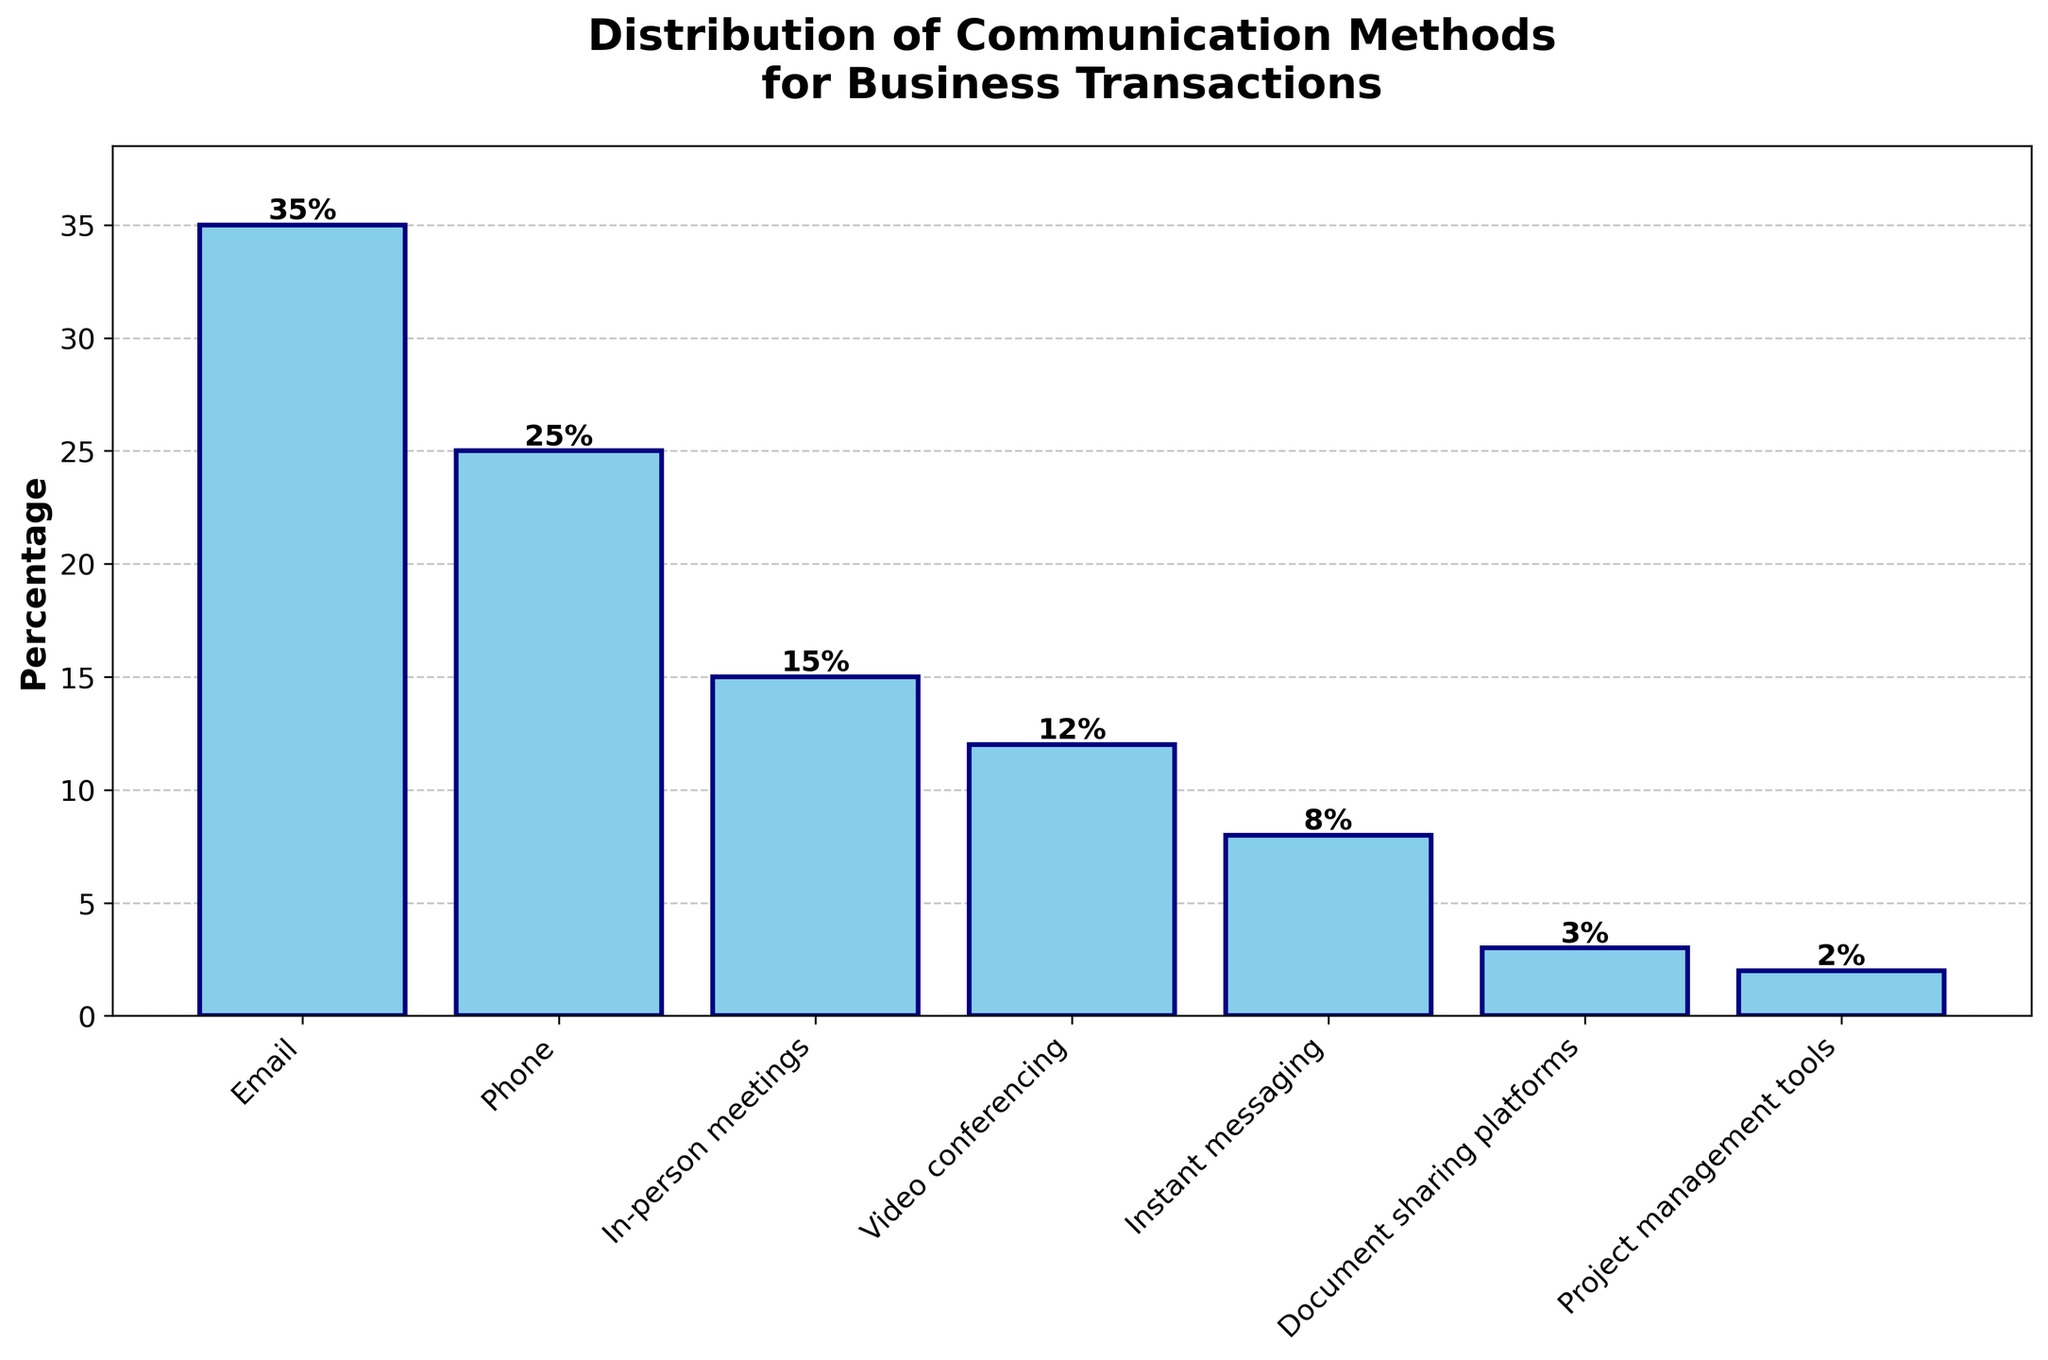What's the total percentage of methods that use digital communication (Email, Phone, Video conferencing, Instant messaging, Document sharing platforms)? Sum the percentages of Email (35), Phone (25), Video conferencing (12), Instant messaging (8), and Document sharing platforms (3). 35 + 25 + 12 + 8 + 3 = 83
Answer: 83 Which communication method has the highest percentage? Identify the tallest bar in the bar chart, which represents Email at 35%.
Answer: Email What is the percentage difference between Email and Phone? Subtract the percentage of Phone (25) from Email (35). 35 - 25 = 10
Answer: 10 What is the combined percentage of In-person meetings and Video conferencing? Add the percentages of In-person meetings (15) and Video conferencing (12). 15 + 12 = 27
Answer: 27 Are there more methods that have percentages above 10% or below 10%? Count the methods above 10% (Email, Phone, In-person meetings, Video conferencing) and below 10% (Instant messaging, Document sharing platforms, Project management tools). 4 methods above 10%, 3 methods below 10%.
Answer: Above 10% What percentage of methods use primarily face-to-face communication (In-person meetings and Video conferencing)? Sum the percentages of In-person meetings (15) and Video conferencing (12). 15 + 12 = 27
Answer: 27 How does the percentage of Instant messaging compare to that of Document sharing platforms and Project management tools combined? Compare the percentage of Instant messaging (8) to the sum of Document sharing platforms (3) and Project management tools (2). Instant messaging (8%) is greater than Document sharing platforms + Project management tools (3 + 2 = 5%).
Answer: Instant messaging Which has a higher percentage, In-person meetings or Video conferencing? Compare the percentages of In-person meetings (15) and Video conferencing (12). In-person meetings have a higher percentage.
Answer: In-person meetings What percentage of transactions use non-verbal methods (Email, Document sharing platforms, Project management tools)? Add the percentages of Email (35), Document sharing platforms (3), and Project management tools (2). 35 + 3 + 2 = 40
Answer: 40 